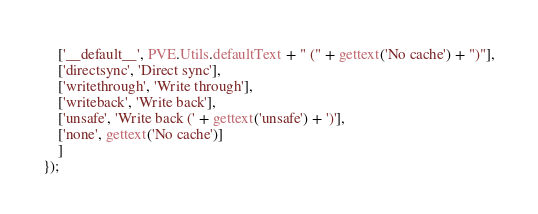Convert code to text. <code><loc_0><loc_0><loc_500><loc_500><_JavaScript_>	['__default__', PVE.Utils.defaultText + " (" + gettext('No cache') + ")"],
	['directsync', 'Direct sync'],
	['writethrough', 'Write through'],
	['writeback', 'Write back'],
	['unsafe', 'Write back (' + gettext('unsafe') + ')'],
	['none', gettext('No cache')]
    ]
});
</code> 